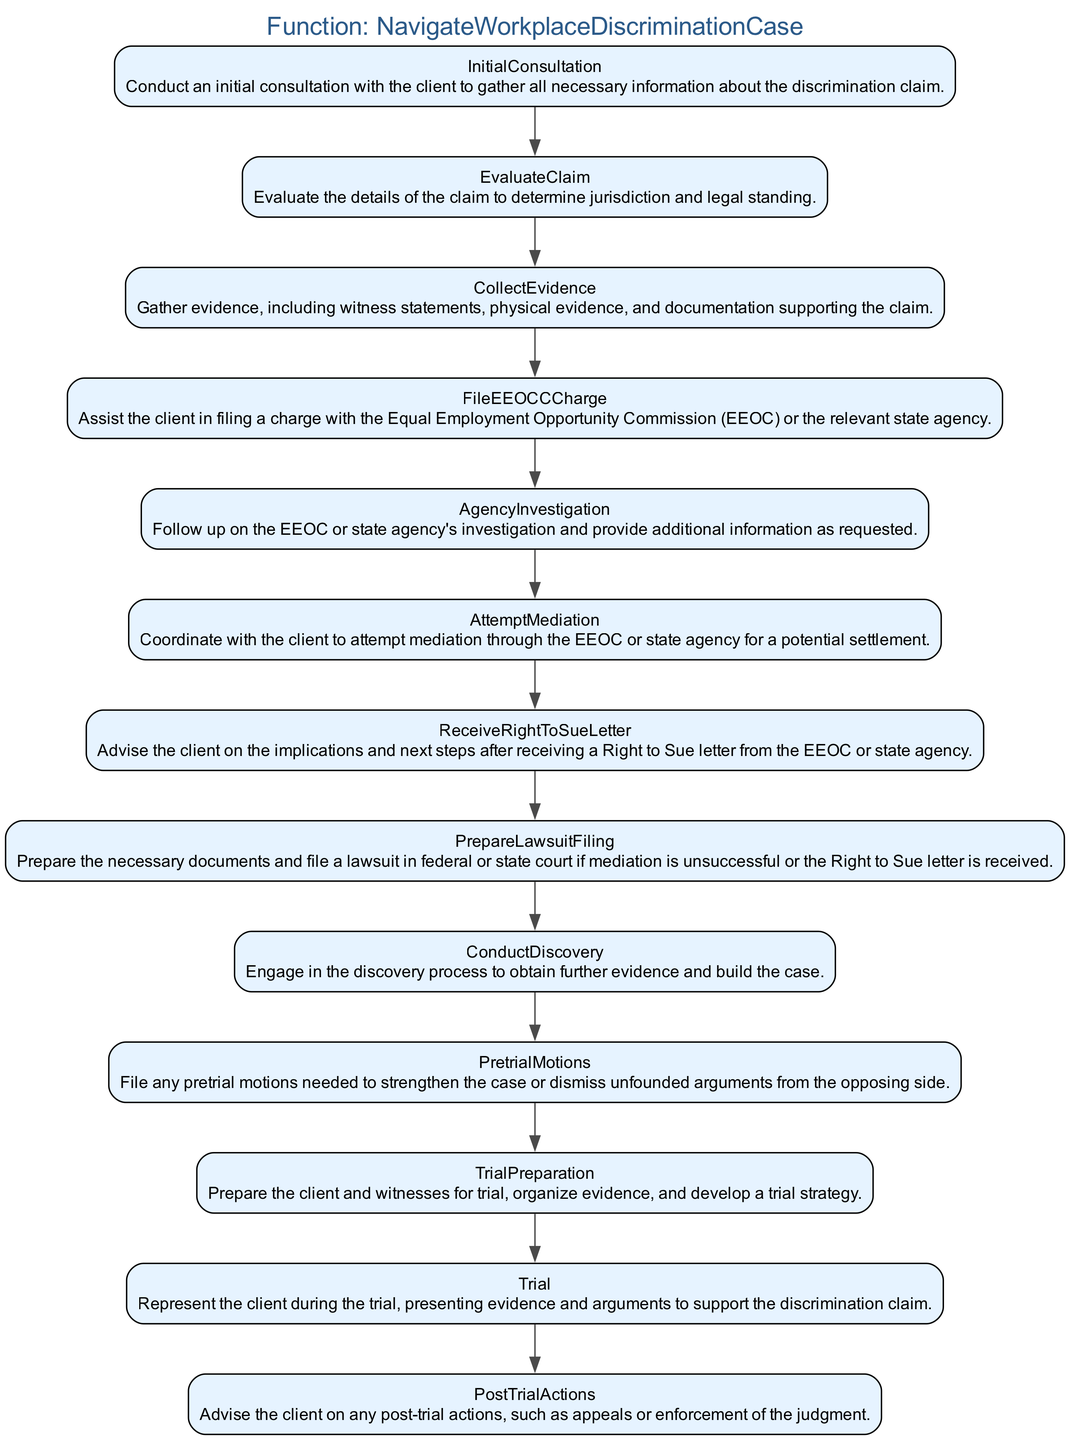What is the first step in navigating a workplace discrimination case? The first step in the flowchart is labeled "InitialConsultation". This indicates that the initial meeting with the client is fundamental to starting the process of addressing discrimination claims.
Answer: Initial Consultation How many steps are involved in the process? By counting each individual step listed in the flowchart, we see there are thirteen distinct steps outlined for navigating the workplace discrimination case.
Answer: Thirteen What is the purpose of the “FileEEOCCCharge” step? The "FileEEOCCCharge" step specifically involves assisting the client in formally submitting a charge to the Equal Employment Opportunity Commission or a related state agency, which is crucial for initiating a legal procedure.
Answer: Assist in filing a charge What follows immediately after “CollectEvidence”? Immediately after the "CollectEvidence" step, the flowchart indicates "FileEEOCCCharge", showing that once evidence is gathered, the next action is to file the charge with the appropriate agency.
Answer: File EEOCC Charge What is the last step in the process? The final step in the diagram is "PostTrialActions", indicating the concluding actions taken after a trial, including discussing potential appeals or enforcing the judgment.
Answer: Post Trial Actions What are the implications of receiving a “Right to Sue” letter? Following the "ReceiveRightToSueLetter" step, clients receive advice regarding the implications of this letter, which signifies a pivotal moment allowing them to proceed with a lawsuit if mediation fails.
Answer: Advise on implications Which step focuses on mediation? The "AttemptMediation" step deals specifically with coordinating an effort to mediate the dispute through the EEOC or the relevant state agency, aiming for an amicable resolution without proceeding to trial.
Answer: Attempt Mediation What is conducted after “PrepareLawsuitFiling”? After "PrepareLawsuitFiling", the next stage in the process is "ConductDiscovery", where both parties seek to gather more evidence to support their cases.
Answer: Conduct Discovery What is required to file a lawsuit? To file a lawsuit, the necessary documents must be prepared as outlined in the "PrepareLawsuitFiling" step, indicating a formal transition to legal proceedings in court.
Answer: Necessary documents and filing 